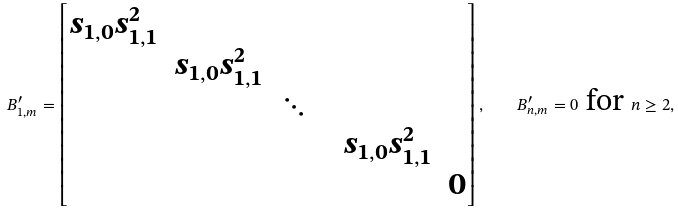Convert formula to latex. <formula><loc_0><loc_0><loc_500><loc_500>B ^ { \prime } _ { 1 , m } = \left [ \begin{matrix} s _ { 1 , 0 } s _ { 1 , 1 } ^ { 2 } & \\ & s _ { 1 , 0 } s _ { 1 , 1 } ^ { 2 } & & \\ & & \ddots & \\ & & & & s _ { 1 , 0 } s _ { 1 , 1 } ^ { 2 } \\ & & & & & 0 \\ \end{matrix} \right ] , \quad B ^ { \prime } _ { n , m } = 0 \text { for } n \geq 2 ,</formula> 